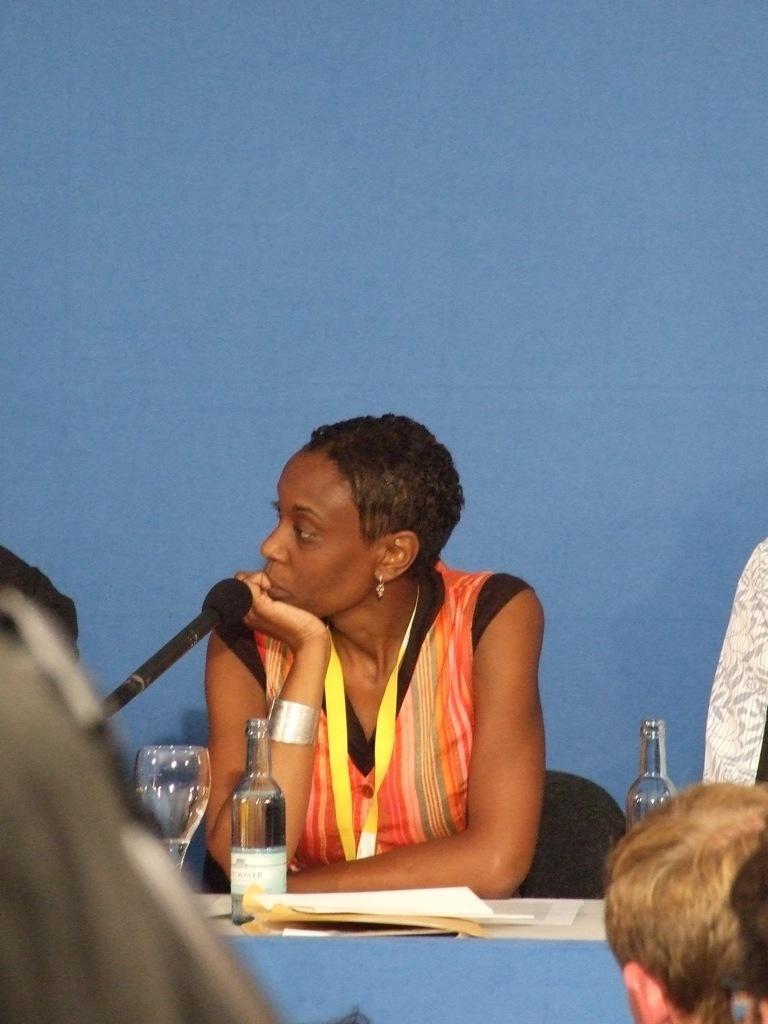Could you give a brief overview of what you see in this image? In this picture, we see woman sitting on chair is wearing yellow ID card. In front of her, we see a table on which book, glass bottle, microphone and glass are placed. On right bottom of picture, we see man sitting on chair and behind her, we see a blue wall. 